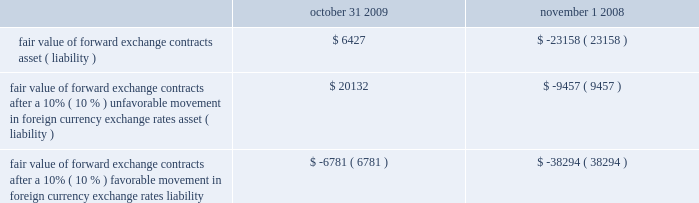Interest rate to a variable interest rate based on the three-month libor plus 2.05% ( 2.05 % ) ( 2.34% ( 2.34 % ) as of october 31 , 2009 ) .
If libor changes by 100 basis points , our annual interest expense would change by $ 3.8 million .
Foreign currency exposure as more fully described in note 2i .
In the notes to consolidated financial statements contained in item 8 of this annual report on form 10-k , we regularly hedge our non-u.s .
Dollar-based exposures by entering into forward foreign currency exchange contracts .
The terms of these contracts are for periods matching the duration of the underlying exposure and generally range from one month to twelve months .
Currently , our largest foreign currency exposure is the euro , primarily because our european operations have the highest proportion of our local currency denominated expenses .
Relative to foreign currency exposures existing at october 31 , 2009 and november 1 , 2008 , a 10% ( 10 % ) unfavorable movement in foreign currency exchange rates over the course of the year would not expose us to significant losses in earnings or cash flows because we hedge a high proportion of our year-end exposures against fluctuations in foreign currency exchange rates .
The market risk associated with our derivative instruments results from currency exchange rate or interest rate movements that are expected to offset the market risk of the underlying transactions , assets and liabilities being hedged .
The counterparties to the agreements relating to our foreign exchange instruments consist of a number of major international financial institutions with high credit ratings .
We do not believe that there is significant risk of nonperformance by these counterparties because we continually monitor the credit ratings of such counterparties .
While the contract or notional amounts of derivative financial instruments provide one measure of the volume of these transactions , they do not represent the amount of our exposure to credit risk .
The amounts potentially subject to credit risk ( arising from the possible inability of counterparties to meet the terms of their contracts ) are generally limited to the amounts , if any , by which the counterparties 2019 obligations under the contracts exceed our obligations to the counterparties .
The table illustrates the effect that a 10% ( 10 % ) unfavorable or favorable movement in foreign currency exchange rates , relative to the u.s .
Dollar , would have on the fair value of our forward exchange contracts as of october 31 , 2009 and november 1 , 2008: .
Fair value of forward exchange contracts after a 10% ( 10 % ) unfavorable movement in foreign currency exchange rates asset ( liability ) .
$ 20132 $ ( 9457 ) fair value of forward exchange contracts after a 10% ( 10 % ) favorable movement in foreign currency exchange rates liability .
$ ( 6781 ) $ ( 38294 ) the calculation assumes that each exchange rate would change in the same direction relative to the u.s .
Dollar .
In addition to the direct effects of changes in exchange rates , such changes typically affect the volume of sales or the foreign currency sales price as competitors 2019 products become more or less attractive .
Our sensitivity analysis of the effects of changes in foreign currency exchange rates does not factor in a potential change in sales levels or local currency selling prices. .
What is the the interest expense in 2009? 
Computations: (3.8 / (100 / 100))
Answer: 3.8. Interest rate to a variable interest rate based on the three-month libor plus 2.05% ( 2.05 % ) ( 2.34% ( 2.34 % ) as of october 31 , 2009 ) .
If libor changes by 100 basis points , our annual interest expense would change by $ 3.8 million .
Foreign currency exposure as more fully described in note 2i .
In the notes to consolidated financial statements contained in item 8 of this annual report on form 10-k , we regularly hedge our non-u.s .
Dollar-based exposures by entering into forward foreign currency exchange contracts .
The terms of these contracts are for periods matching the duration of the underlying exposure and generally range from one month to twelve months .
Currently , our largest foreign currency exposure is the euro , primarily because our european operations have the highest proportion of our local currency denominated expenses .
Relative to foreign currency exposures existing at october 31 , 2009 and november 1 , 2008 , a 10% ( 10 % ) unfavorable movement in foreign currency exchange rates over the course of the year would not expose us to significant losses in earnings or cash flows because we hedge a high proportion of our year-end exposures against fluctuations in foreign currency exchange rates .
The market risk associated with our derivative instruments results from currency exchange rate or interest rate movements that are expected to offset the market risk of the underlying transactions , assets and liabilities being hedged .
The counterparties to the agreements relating to our foreign exchange instruments consist of a number of major international financial institutions with high credit ratings .
We do not believe that there is significant risk of nonperformance by these counterparties because we continually monitor the credit ratings of such counterparties .
While the contract or notional amounts of derivative financial instruments provide one measure of the volume of these transactions , they do not represent the amount of our exposure to credit risk .
The amounts potentially subject to credit risk ( arising from the possible inability of counterparties to meet the terms of their contracts ) are generally limited to the amounts , if any , by which the counterparties 2019 obligations under the contracts exceed our obligations to the counterparties .
The table illustrates the effect that a 10% ( 10 % ) unfavorable or favorable movement in foreign currency exchange rates , relative to the u.s .
Dollar , would have on the fair value of our forward exchange contracts as of october 31 , 2009 and november 1 , 2008: .
Fair value of forward exchange contracts after a 10% ( 10 % ) unfavorable movement in foreign currency exchange rates asset ( liability ) .
$ 20132 $ ( 9457 ) fair value of forward exchange contracts after a 10% ( 10 % ) favorable movement in foreign currency exchange rates liability .
$ ( 6781 ) $ ( 38294 ) the calculation assumes that each exchange rate would change in the same direction relative to the u.s .
Dollar .
In addition to the direct effects of changes in exchange rates , such changes typically affect the volume of sales or the foreign currency sales price as competitors 2019 products become more or less attractive .
Our sensitivity analysis of the effects of changes in foreign currency exchange rates does not factor in a potential change in sales levels or local currency selling prices. .
What is the lobor rate as of october 31 , 2009? 
Computations: (2.34% - 2.05%)
Answer: 0.0029. 